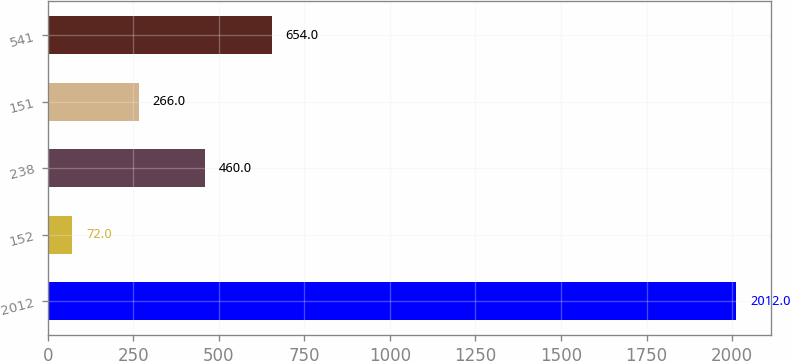<chart> <loc_0><loc_0><loc_500><loc_500><bar_chart><fcel>2012<fcel>152<fcel>238<fcel>151<fcel>541<nl><fcel>2012<fcel>72<fcel>460<fcel>266<fcel>654<nl></chart> 